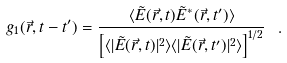Convert formula to latex. <formula><loc_0><loc_0><loc_500><loc_500>g _ { 1 } ( \vec { r } , t - t ^ { \prime } ) = \frac { \langle \tilde { E } ( \vec { r } , t ) \tilde { E } ^ { * } ( \vec { r } , t ^ { \prime } ) \rangle } { \left [ \langle | \tilde { E } ( \vec { r } , t ) | ^ { 2 } \rangle \langle | \tilde { E } ( \vec { r } , t ^ { \prime } ) | ^ { 2 } \rangle \right ] ^ { 1 / 2 } } \ .</formula> 